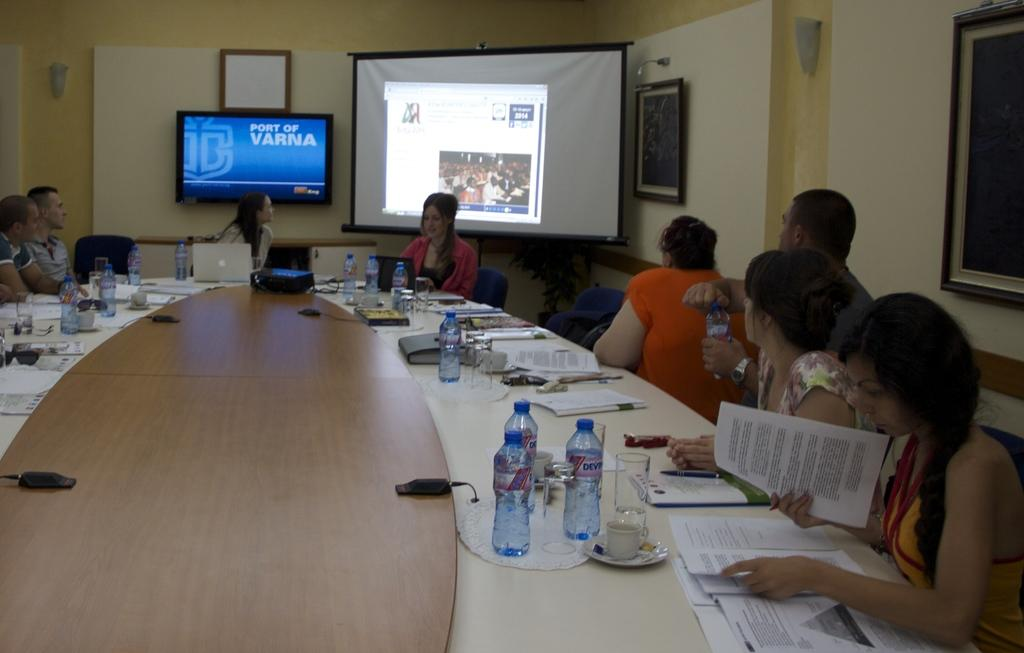What are the people in the image doing? The people in the image are seated. What type of furniture is in the image? There is a chair in the image. What is the large, flat surface in the image used for? There is a projector screen in the image, which is likely used for presentations or watching videos. What electronic device is in the image? There is a television in the image. What type of written material is present in the image? Papers are present in the image. What type of beverage container is visible in the image? Water bottles are visible in the image. What device is on the table in the image? There is a laptop on the table in the image. How many arms are visible in the image? There is no specific mention of arms in the image, so it is not possible to determine the number of arms visible. What type of experience can be gained from the image? The image itself does not provide an experience; it is a static representation of a scene. 